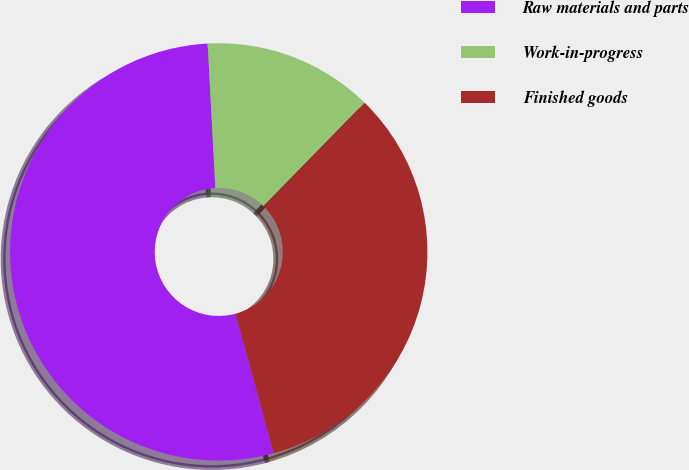Convert chart. <chart><loc_0><loc_0><loc_500><loc_500><pie_chart><fcel>Raw materials and parts<fcel>Work-in-progress<fcel>Finished goods<nl><fcel>53.4%<fcel>13.17%<fcel>33.44%<nl></chart> 